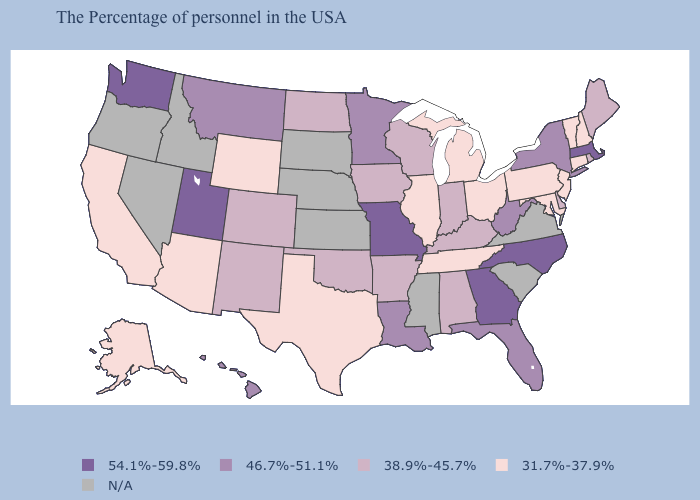Name the states that have a value in the range 46.7%-51.1%?
Write a very short answer. New York, West Virginia, Florida, Louisiana, Minnesota, Montana, Hawaii. Among the states that border North Carolina , does Georgia have the highest value?
Concise answer only. Yes. Does the first symbol in the legend represent the smallest category?
Quick response, please. No. Which states have the lowest value in the MidWest?
Quick response, please. Ohio, Michigan, Illinois. What is the value of Texas?
Write a very short answer. 31.7%-37.9%. Which states hav the highest value in the West?
Give a very brief answer. Utah, Washington. Name the states that have a value in the range 46.7%-51.1%?
Answer briefly. New York, West Virginia, Florida, Louisiana, Minnesota, Montana, Hawaii. What is the value of Florida?
Quick response, please. 46.7%-51.1%. What is the value of Kansas?
Short answer required. N/A. Which states have the highest value in the USA?
Quick response, please. Massachusetts, North Carolina, Georgia, Missouri, Utah, Washington. Among the states that border New York , does Massachusetts have the highest value?
Answer briefly. Yes. What is the value of Maine?
Concise answer only. 38.9%-45.7%. 